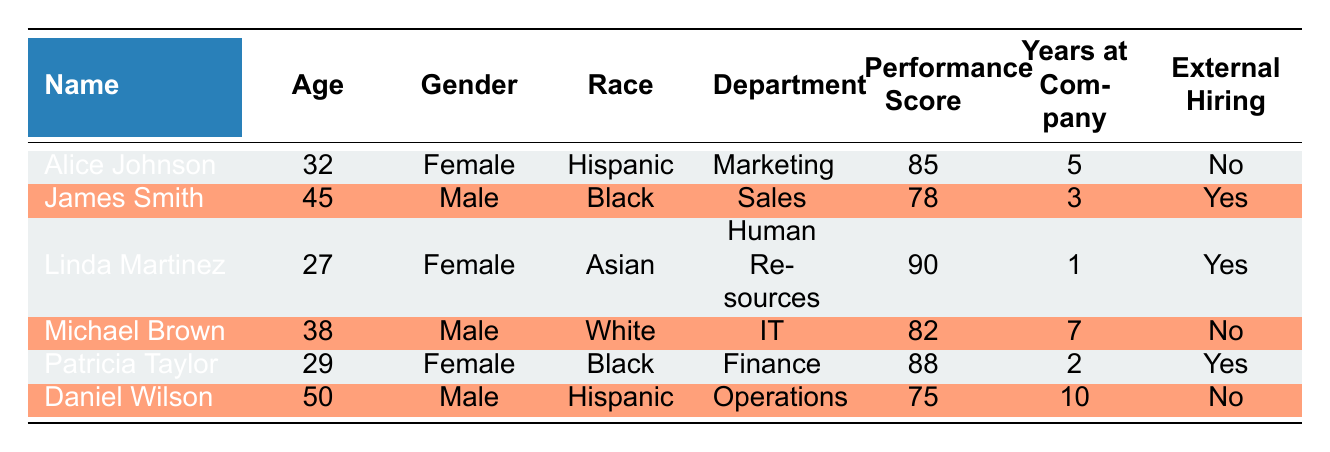What is the performance score of Linda Martinez? Referring to the table, Linda Martinez has a performance score listed in the "Performance Score" column. The specific score for her is 90.
Answer: 90 How many employees are in the Marketing department? From the table, we can see that there is only one employee listed in the Marketing department, which is Alice Johnson.
Answer: 1 What is the average performance score of employees who were externally hired? The performance scores of the externally hired employees (James Smith, Linda Martinez, Patricia Taylor) are 78, 90, and 88 respectively. To find the average, we sum these values: 78 + 90 + 88 = 256. Then, we divide by the number of employees: 256 / 3 = approximately 85.33.
Answer: 85.33 Are there any male employees with a performance score greater than 80? Filtering the table, we find that Michael Brown has a performance score of 82, and James Smith has a score of 78. Therefore, only Michael Brown meets the criteria.
Answer: Yes Which demographic group (gender) has the highest average performance score? First, we separate the performance scores by gender. The scores for females (Alice Johnson: 85, Linda Martinez: 90, Patricia Taylor: 88) sum to 263 for 3 females, averaging 263 / 3 = approximately 87.67. The male scores (James Smith: 78, Michael Brown: 82, Daniel Wilson: 75) sum to 235 for 3 males, averaging 235 / 3 = approximately 78.33. Females have a higher average performance score.
Answer: Female How many years, on average, do employees in the Finance department have at the company? The only employee in the Finance department is Patricia Taylor, who has been at the company for 2 years. Since there's only one employee, the average is simply 2 years.
Answer: 2 Is there a Hispanic employee with more than 5 years at the company? Looking at the table, Daniel Wilson is Hispanic with 10 years at the company, which is more than 5 years.
Answer: Yes What is the performance score difference between the highest and lowest scoring employees? The highest score is 90 (Linda Martinez) and the lowest score is 75 (Daniel Wilson). The difference is calculated as 90 - 75 = 15.
Answer: 15 